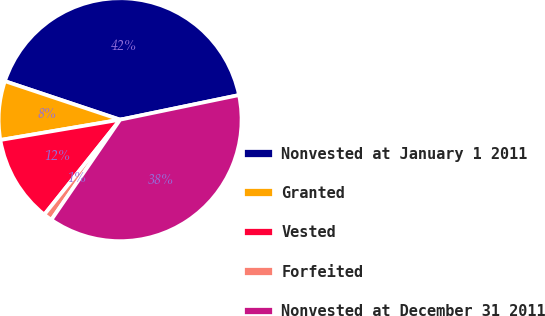Convert chart to OTSL. <chart><loc_0><loc_0><loc_500><loc_500><pie_chart><fcel>Nonvested at January 1 2011<fcel>Granted<fcel>Vested<fcel>Forfeited<fcel>Nonvested at December 31 2011<nl><fcel>41.61%<fcel>7.81%<fcel>11.6%<fcel>1.15%<fcel>37.82%<nl></chart> 